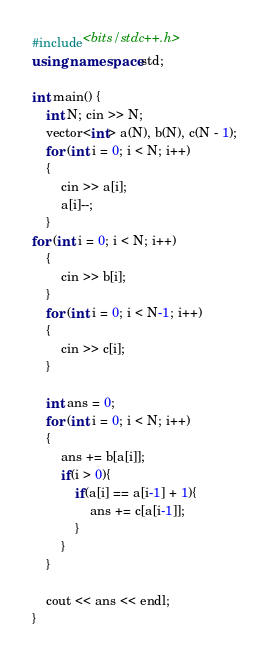<code> <loc_0><loc_0><loc_500><loc_500><_C++_>#include<bits/stdc++.h>
using namespace std;

int main() {
    int N; cin >> N;
    vector<int> a(N), b(N), c(N - 1);
    for (int i = 0; i < N; i++)
    {
        cin >> a[i];
        a[i]--;
    }
for (int i = 0; i < N; i++)
    {
        cin >> b[i];
    }
    for (int i = 0; i < N-1; i++)
    {
        cin >> c[i];
    }

    int ans = 0;
    for (int i = 0; i < N; i++)
    {
        ans += b[a[i]];
        if(i > 0){
            if(a[i] == a[i-1] + 1){
                ans += c[a[i-1]];
            }
        }
    }

    cout << ans << endl;
}</code> 